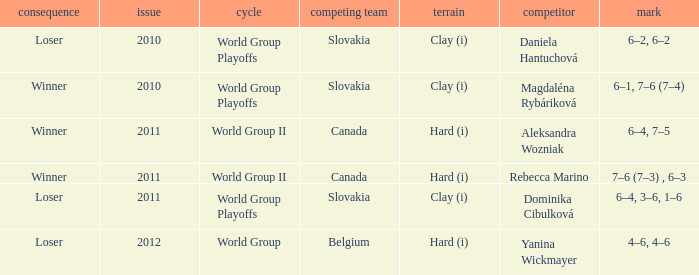What was the game edition when they played on the clay (i) surface and the outcome was a winner? 2010.0. 